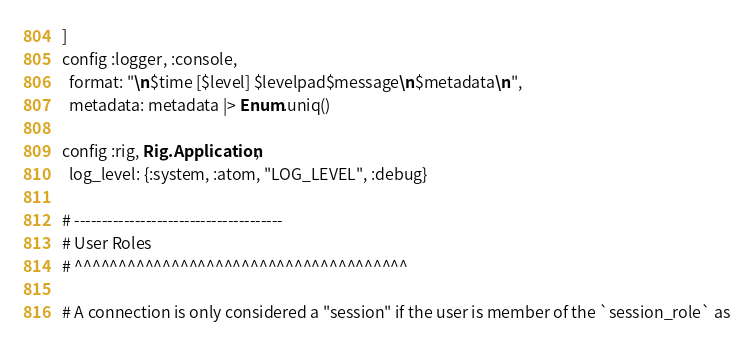<code> <loc_0><loc_0><loc_500><loc_500><_Elixir_>]
config :logger, :console,
  format: "\n$time [$level] $levelpad$message\n$metadata\n",
  metadata: metadata |> Enum.uniq()

config :rig, Rig.Application,
  log_level: {:system, :atom, "LOG_LEVEL", :debug}

# --------------------------------------
# User Roles
# ^^^^^^^^^^^^^^^^^^^^^^^^^^^^^^^^^^^^^^

# A connection is only considered a "session" if the user is member of the `session_role` as</code> 